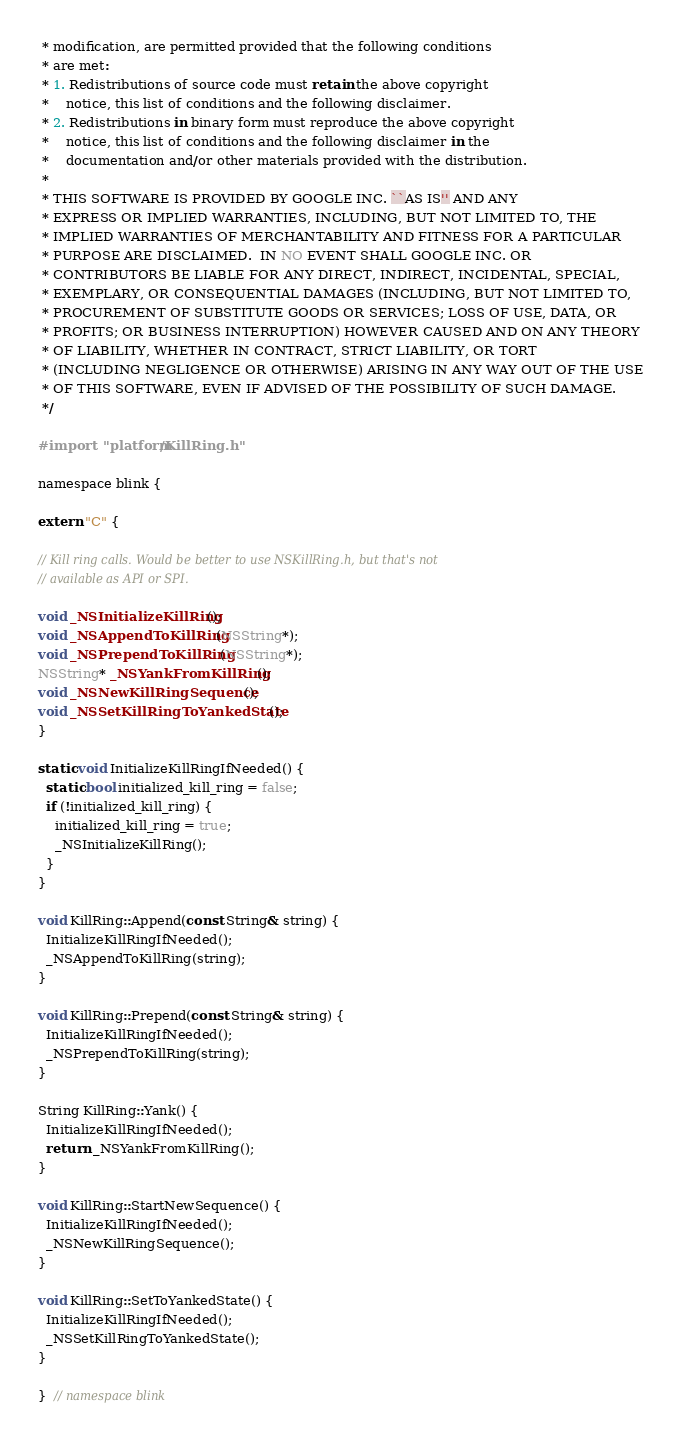<code> <loc_0><loc_0><loc_500><loc_500><_ObjectiveC_> * modification, are permitted provided that the following conditions
 * are met:
 * 1. Redistributions of source code must retain the above copyright
 *    notice, this list of conditions and the following disclaimer.
 * 2. Redistributions in binary form must reproduce the above copyright
 *    notice, this list of conditions and the following disclaimer in the
 *    documentation and/or other materials provided with the distribution.
 *
 * THIS SOFTWARE IS PROVIDED BY GOOGLE INC. ``AS IS'' AND ANY
 * EXPRESS OR IMPLIED WARRANTIES, INCLUDING, BUT NOT LIMITED TO, THE
 * IMPLIED WARRANTIES OF MERCHANTABILITY AND FITNESS FOR A PARTICULAR
 * PURPOSE ARE DISCLAIMED.  IN NO EVENT SHALL GOOGLE INC. OR
 * CONTRIBUTORS BE LIABLE FOR ANY DIRECT, INDIRECT, INCIDENTAL, SPECIAL,
 * EXEMPLARY, OR CONSEQUENTIAL DAMAGES (INCLUDING, BUT NOT LIMITED TO,
 * PROCUREMENT OF SUBSTITUTE GOODS OR SERVICES; LOSS OF USE, DATA, OR
 * PROFITS; OR BUSINESS INTERRUPTION) HOWEVER CAUSED AND ON ANY THEORY
 * OF LIABILITY, WHETHER IN CONTRACT, STRICT LIABILITY, OR TORT
 * (INCLUDING NEGLIGENCE OR OTHERWISE) ARISING IN ANY WAY OUT OF THE USE
 * OF THIS SOFTWARE, EVEN IF ADVISED OF THE POSSIBILITY OF SUCH DAMAGE.
 */

#import "platform/KillRing.h"

namespace blink {

extern "C" {

// Kill ring calls. Would be better to use NSKillRing.h, but that's not
// available as API or SPI.

void _NSInitializeKillRing();
void _NSAppendToKillRing(NSString*);
void _NSPrependToKillRing(NSString*);
NSString* _NSYankFromKillRing();
void _NSNewKillRingSequence();
void _NSSetKillRingToYankedState();
}

static void InitializeKillRingIfNeeded() {
  static bool initialized_kill_ring = false;
  if (!initialized_kill_ring) {
    initialized_kill_ring = true;
    _NSInitializeKillRing();
  }
}

void KillRing::Append(const String& string) {
  InitializeKillRingIfNeeded();
  _NSAppendToKillRing(string);
}

void KillRing::Prepend(const String& string) {
  InitializeKillRingIfNeeded();
  _NSPrependToKillRing(string);
}

String KillRing::Yank() {
  InitializeKillRingIfNeeded();
  return _NSYankFromKillRing();
}

void KillRing::StartNewSequence() {
  InitializeKillRingIfNeeded();
  _NSNewKillRingSequence();
}

void KillRing::SetToYankedState() {
  InitializeKillRingIfNeeded();
  _NSSetKillRingToYankedState();
}

}  // namespace blink
</code> 